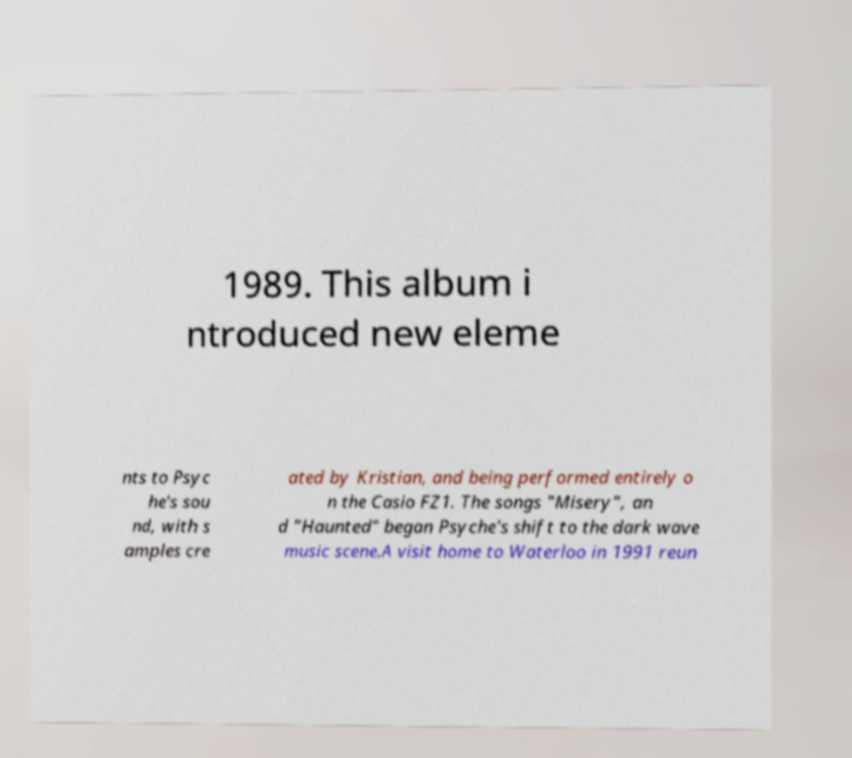Could you extract and type out the text from this image? 1989. This album i ntroduced new eleme nts to Psyc he's sou nd, with s amples cre ated by Kristian, and being performed entirely o n the Casio FZ1. The songs "Misery", an d "Haunted" began Psyche's shift to the dark wave music scene.A visit home to Waterloo in 1991 reun 